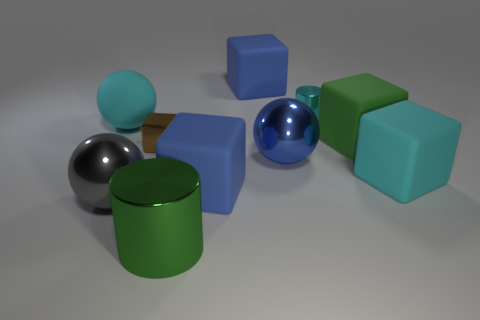What is the material of the green cube that is the same size as the blue metallic thing?
Your answer should be compact. Rubber. What shape is the object that is in front of the cyan block and left of the brown block?
Your answer should be very brief. Sphere. There is a metal cylinder that is the same size as the gray thing; what color is it?
Your answer should be compact. Green. Do the cylinder behind the tiny metal block and the matte thing behind the tiny cyan shiny thing have the same size?
Your response must be concise. No. There is a blue matte object that is in front of the blue shiny thing behind the large metallic sphere that is to the left of the tiny brown shiny object; how big is it?
Offer a terse response. Large. There is a tiny thing that is behind the cyan rubber thing that is left of the green metallic thing; what shape is it?
Your response must be concise. Cylinder. Does the cylinder in front of the cyan rubber sphere have the same color as the metallic cube?
Provide a succinct answer. No. What color is the big rubber object that is both in front of the small cyan metal object and behind the green matte thing?
Make the answer very short. Cyan. Are there any large things made of the same material as the big green cube?
Offer a very short reply. Yes. The rubber sphere has what size?
Provide a succinct answer. Large. 